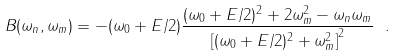<formula> <loc_0><loc_0><loc_500><loc_500>B ( \omega _ { n } , \omega _ { m } ) = - ( \omega _ { 0 } + E / 2 ) \frac { ( \omega _ { 0 } + E / 2 ) ^ { 2 } + 2 \omega _ { m } ^ { 2 } - \omega _ { n } \omega _ { m } } { \left [ ( \omega _ { 0 } + E / 2 ) ^ { 2 } + \omega _ { m } ^ { 2 } \right ] ^ { 2 } } \ .</formula> 